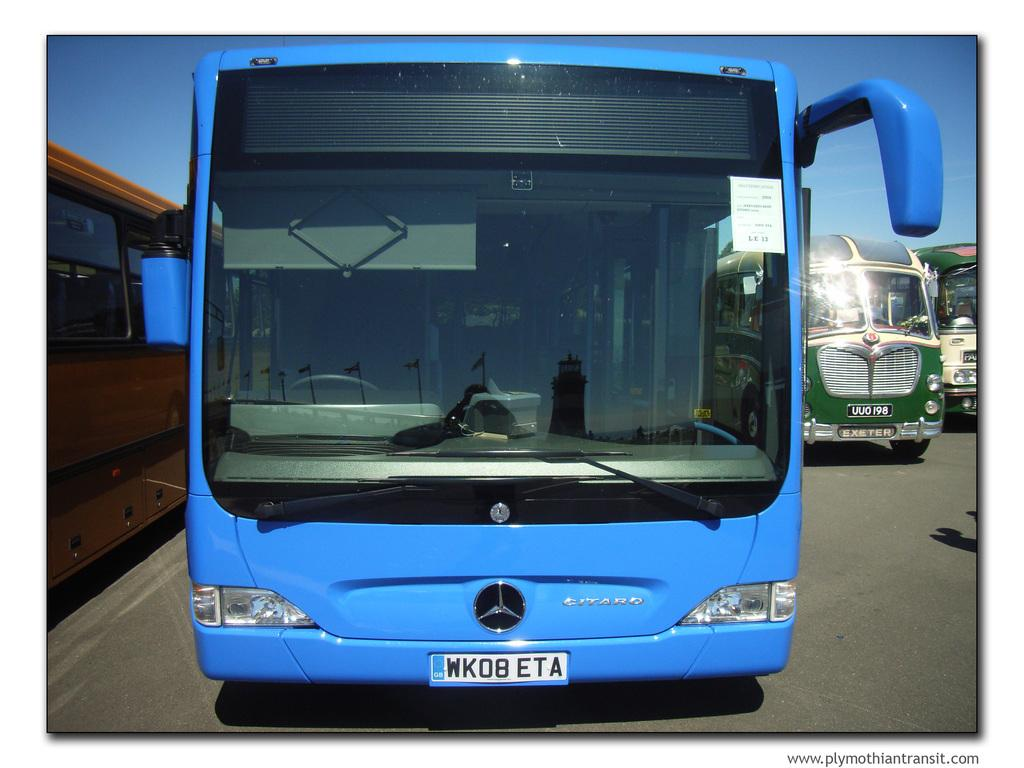<image>
Share a concise interpretation of the image provided. A blue Mercedes bus has license plate number WKO8ETA 